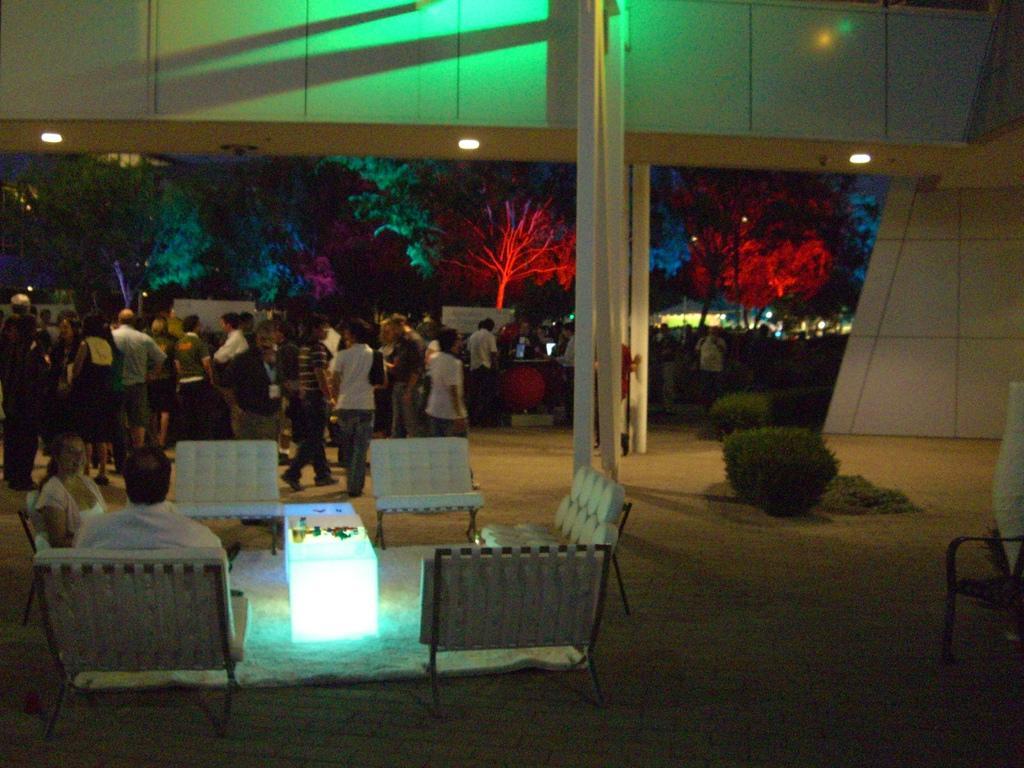Could you give a brief overview of what you see in this image? This image is taken during night time. In this image we can see two persons sitting on the chairs. We can also see the empty chairs. There is a coffee table with lightning. In the background we can see many people standing. We can also see the trees and also plants. Ceiling lights are also visible. We can also see the floor. 